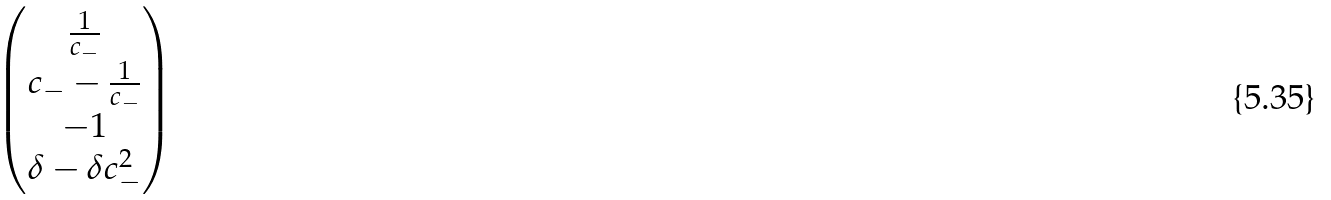<formula> <loc_0><loc_0><loc_500><loc_500>\begin{pmatrix} \frac { 1 } { c _ { - } } \\ c _ { - } - \frac { 1 } { c _ { - } } \\ - 1 \\ \delta - \delta c _ { - } ^ { 2 } \end{pmatrix}</formula> 